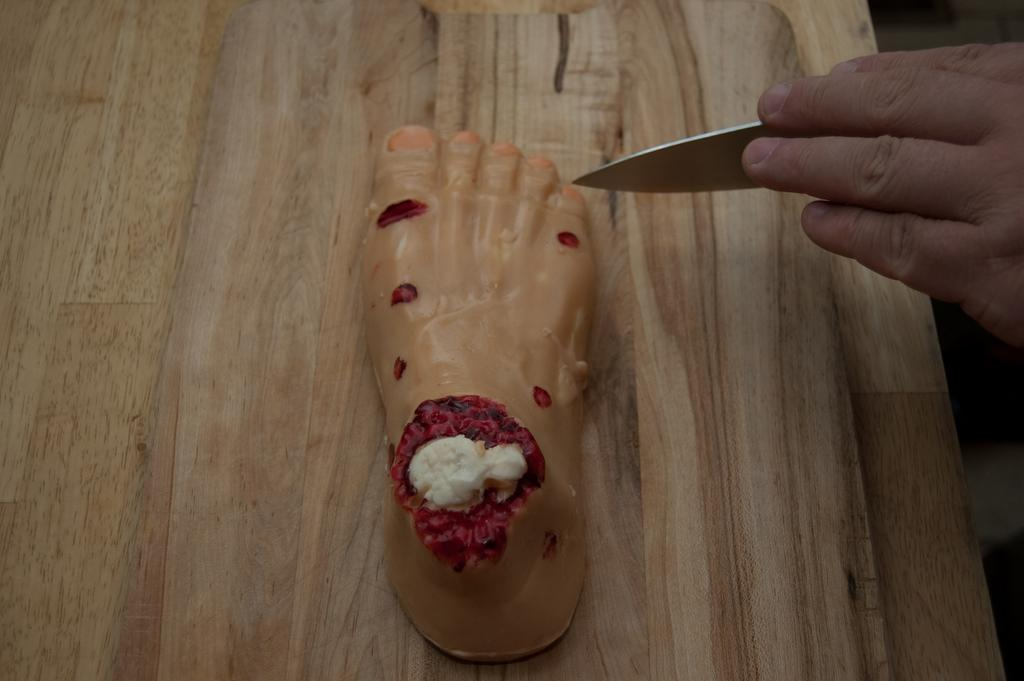What type of cake is shown in the image? There is a leg type structure cake in the image. What is the person in the image holding? The person is holding a knife in the image. What route is the person planning to take with the mine in the image? There is no mention of a route or mine in the image; it only features a cake and a person holding a knife. 